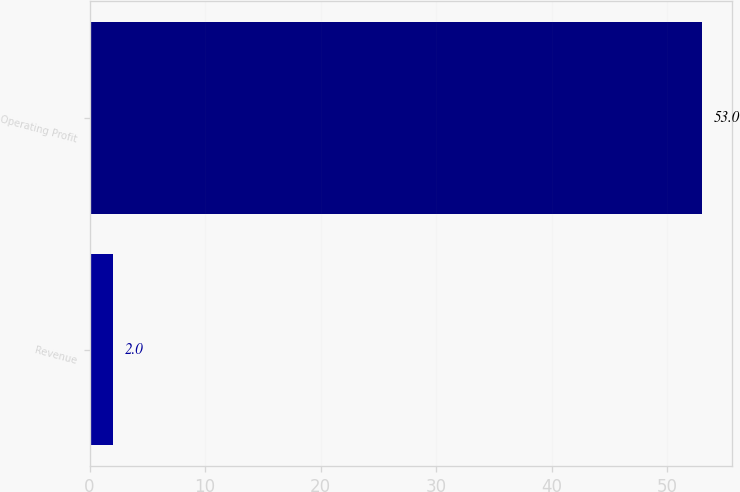<chart> <loc_0><loc_0><loc_500><loc_500><bar_chart><fcel>Revenue<fcel>Operating Profit<nl><fcel>2<fcel>53<nl></chart> 